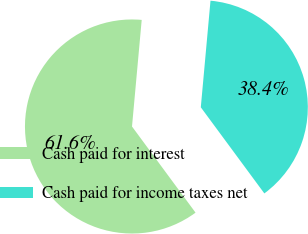<chart> <loc_0><loc_0><loc_500><loc_500><pie_chart><fcel>Cash paid for interest<fcel>Cash paid for income taxes net<nl><fcel>61.56%<fcel>38.44%<nl></chart> 